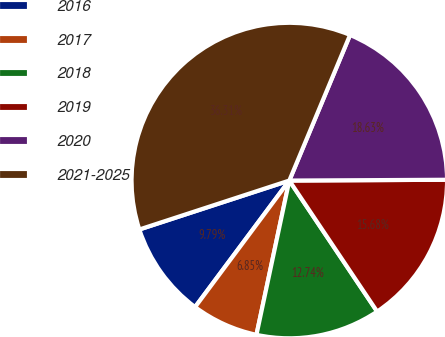Convert chart to OTSL. <chart><loc_0><loc_0><loc_500><loc_500><pie_chart><fcel>2016<fcel>2017<fcel>2018<fcel>2019<fcel>2020<fcel>2021-2025<nl><fcel>9.79%<fcel>6.85%<fcel>12.74%<fcel>15.68%<fcel>18.63%<fcel>36.31%<nl></chart> 